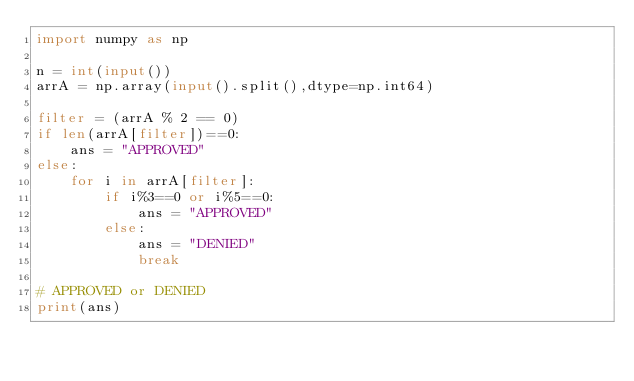<code> <loc_0><loc_0><loc_500><loc_500><_Python_>import numpy as np

n = int(input())
arrA = np.array(input().split(),dtype=np.int64)

filter = (arrA % 2 == 0)
if len(arrA[filter])==0:
    ans = "APPROVED"
else:
    for i in arrA[filter]:
        if i%3==0 or i%5==0:
            ans = "APPROVED"
        else:
            ans = "DENIED"
            break

# APPROVED or DENIED
print(ans)</code> 